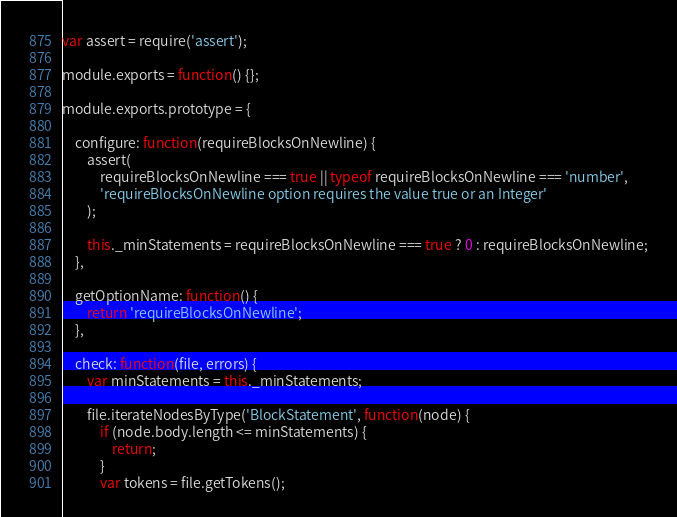Convert code to text. <code><loc_0><loc_0><loc_500><loc_500><_JavaScript_>var assert = require('assert');

module.exports = function() {};

module.exports.prototype = {

    configure: function(requireBlocksOnNewline) {
        assert(
            requireBlocksOnNewline === true || typeof requireBlocksOnNewline === 'number',
            'requireBlocksOnNewline option requires the value true or an Integer'
        );

        this._minStatements = requireBlocksOnNewline === true ? 0 : requireBlocksOnNewline;
    },

    getOptionName: function() {
        return 'requireBlocksOnNewline';
    },

    check: function(file, errors) {
        var minStatements = this._minStatements;

        file.iterateNodesByType('BlockStatement', function(node) {
            if (node.body.length <= minStatements) {
                return;
            }
            var tokens = file.getTokens();</code> 